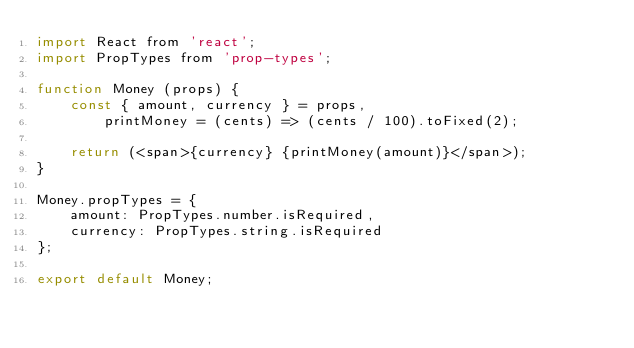<code> <loc_0><loc_0><loc_500><loc_500><_JavaScript_>import React from 'react';
import PropTypes from 'prop-types';

function Money (props) {
    const { amount, currency } = props,
        printMoney = (cents) => (cents / 100).toFixed(2);

    return (<span>{currency} {printMoney(amount)}</span>);
}

Money.propTypes = {
    amount: PropTypes.number.isRequired,
    currency: PropTypes.string.isRequired
};

export default Money;
</code> 